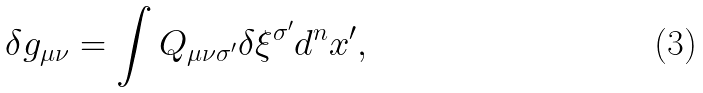<formula> <loc_0><loc_0><loc_500><loc_500>\delta g _ { \mu \nu } = \int Q _ { \mu \nu \sigma ^ { \prime } } \delta \xi ^ { \sigma ^ { \prime } } d ^ { n } x ^ { \prime } ,</formula> 